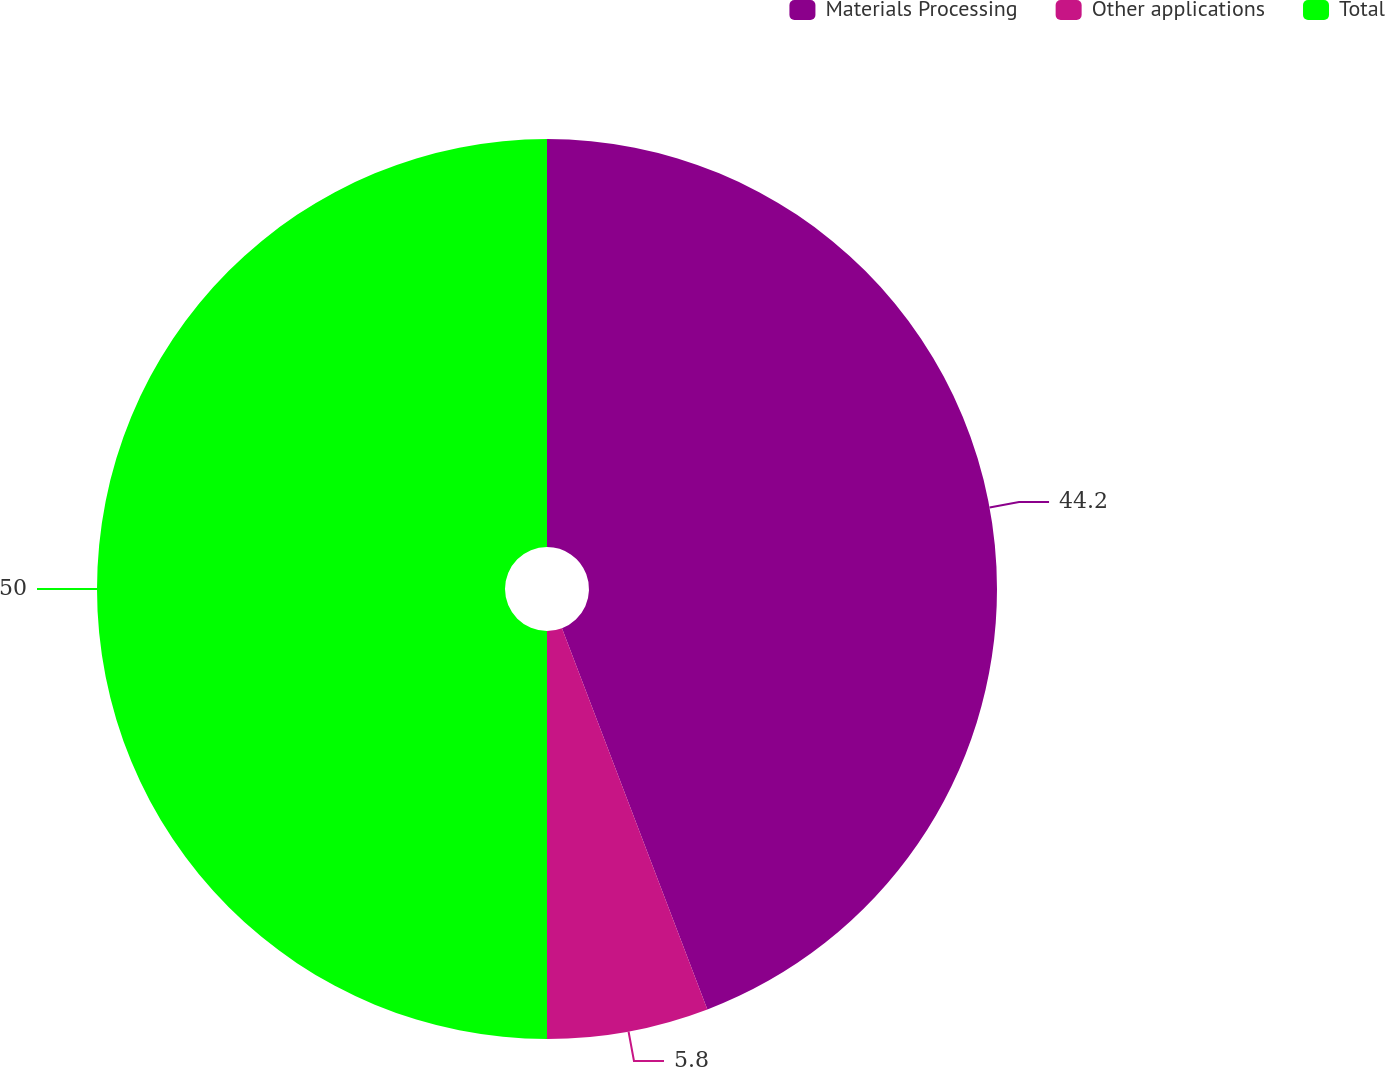Convert chart to OTSL. <chart><loc_0><loc_0><loc_500><loc_500><pie_chart><fcel>Materials Processing<fcel>Other applications<fcel>Total<nl><fcel>44.2%<fcel>5.8%<fcel>50.0%<nl></chart> 